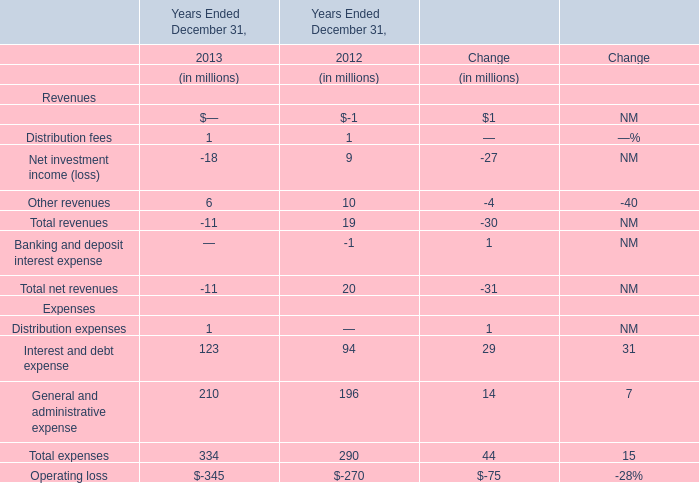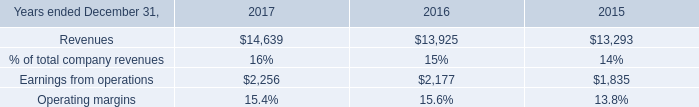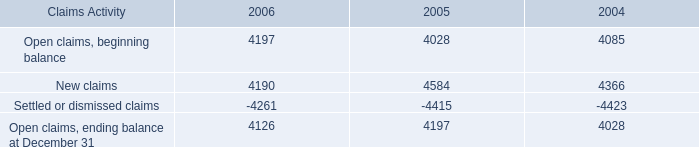If Interest and debt expense develops with the same growth rate in 2013, what will it reach in 2014? (in million) 
Computations: (123 * (1 + ((123 - 94) / 94)))
Answer: 160.94681. 